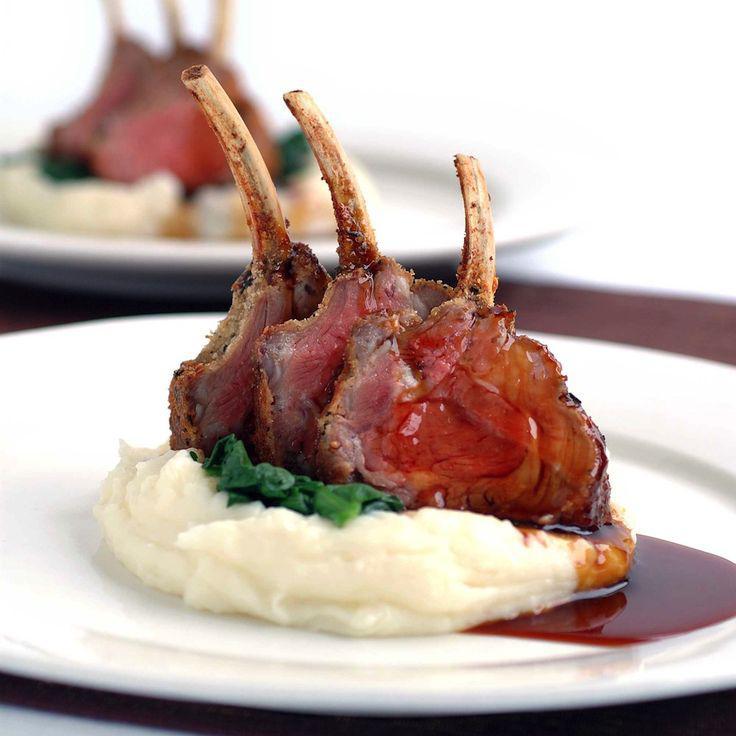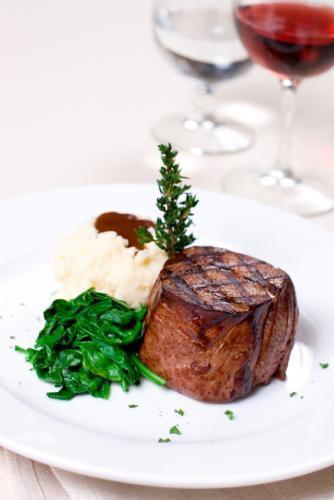The first image is the image on the left, the second image is the image on the right. Given the left and right images, does the statement "A dish includes meatloaf topped with mashed potatoes and brown gravy." hold true? Answer yes or no. No. 